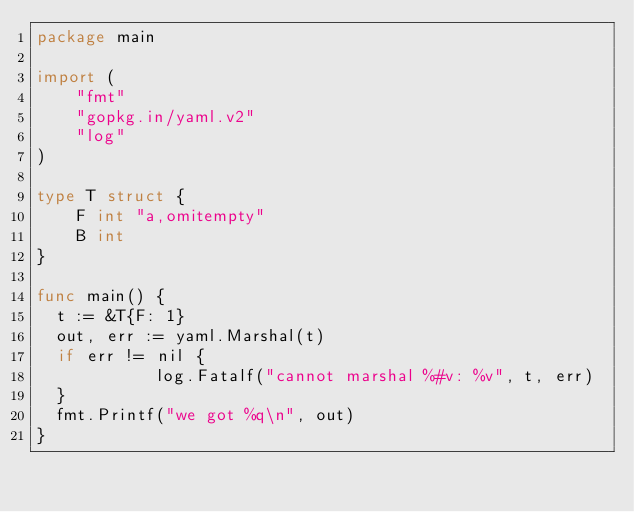<code> <loc_0><loc_0><loc_500><loc_500><_Go_>package main

import (
    "fmt"
    "gopkg.in/yaml.v2"
    "log"
)

type T struct {
    F int "a,omitempty"
    B int
}

func main() {
	t := &T{F: 1}
	out, err := yaml.Marshal(t)
	if err != nil {
            log.Fatalf("cannot marshal %#v: %v", t, err)
	}
	fmt.Printf("we got %q\n", out)
}

</code> 